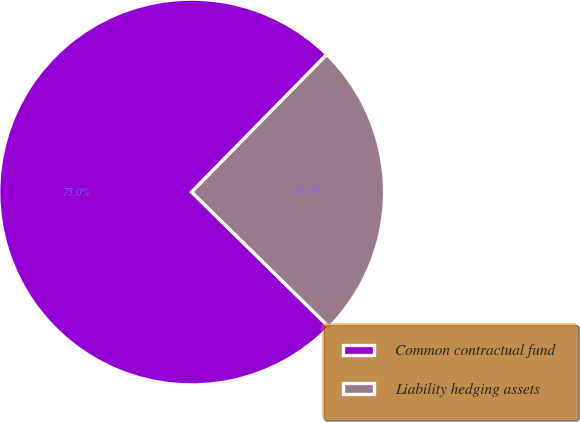<chart> <loc_0><loc_0><loc_500><loc_500><pie_chart><fcel>Common contractual fund<fcel>Liability hedging assets<nl><fcel>75.0%<fcel>25.0%<nl></chart> 